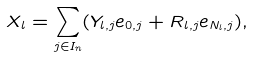<formula> <loc_0><loc_0><loc_500><loc_500>X _ { l } = \sum _ { j \in I _ { n } } ( Y _ { l , j } e _ { 0 , j } + R _ { l , j } e _ { N _ { l } , j } ) ,</formula> 